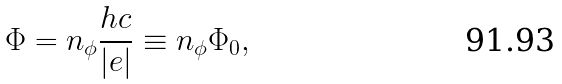Convert formula to latex. <formula><loc_0><loc_0><loc_500><loc_500>\Phi = n _ { \phi } \frac { h c } { | e | } \equiv n _ { \phi } \Phi _ { 0 } ,</formula> 